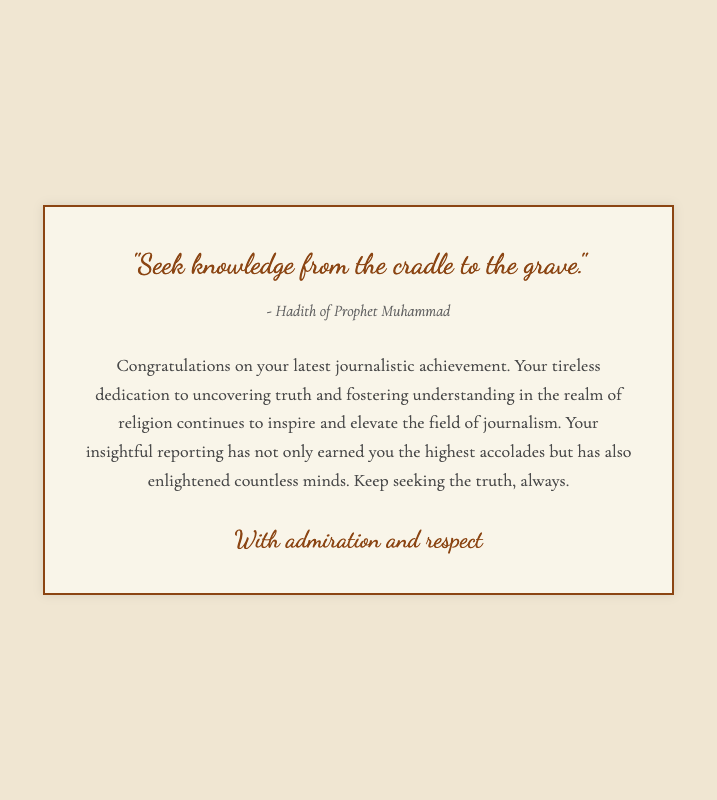What is the quote on the card? The quote is located in the prominent text area of the document and reads: "Seek knowledge from the cradle to the grave."
Answer: "Seek knowledge from the cradle to the grave." Who is the source of the quote? The source is noted directly below the quote, indicating the origin of the thought. It states: "- Hadith of Prophet Muhammad."
Answer: - Hadith of Prophet Muhammad What is the main message of the card? The main message is expressed in the message section that congratulates the recipient on their achievement and encourages their pursuit of truth.
Answer: Congratulations on your latest journalistic achievement What is the background color of the card? The background color is specified in the style section of the document. It is described as a light beige shade.
Answer: #f0e6d2 What type of document is this? The structure and content indicate that this is a congratulatory greeting card dedicated to a journalistic accomplishment.
Answer: Greeting card How does the card describe the recipient's work? The message describes the recipient's work as "tireless dedication to uncovering truth and fostering understanding."
Answer: Tireless dedication to uncovering truth and fostering understanding What font is used for the quote? The font used for the quote is specified in the style section of the document as 'Dancing Script.'
Answer: Dancing Script What is mentioned about the recipient's impact? The message highlights that the recipient's reporting "has not only earned you the highest accolades but has also enlightened countless minds."
Answer: Enlightened countless minds Who signs the card? The card is signed off in the signature section, which indicates the sender's recognition and respect for the recipient.
Answer: With admiration and respect 